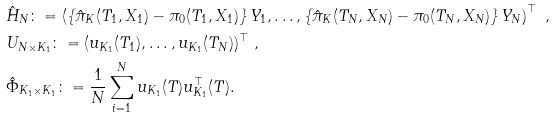<formula> <loc_0><loc_0><loc_500><loc_500>& \hat { H } _ { N } \colon = \left ( \left \{ \hat { \pi } _ { K } ( T _ { 1 } , X _ { 1 } ) - { \pi } _ { 0 } ( T _ { 1 } , X _ { 1 } ) \right \} Y _ { 1 } , \dots , \left \{ \hat { \pi } _ { K } ( T _ { N } , X _ { N } ) - { \pi } _ { 0 } ( T _ { N } , X _ { N } ) \right \} Y _ { N } \right ) ^ { \top } \ , \\ & U _ { N \times K _ { 1 } } \colon = ( u _ { K _ { 1 } } ( T _ { 1 } ) , \dots , u _ { K _ { 1 } } ( T _ { N } ) ) ^ { \top } \ , \\ & \hat { \Phi } _ { K _ { 1 } \times K _ { 1 } } \colon = \frac { 1 } { N } \sum _ { i = 1 } ^ { N } u _ { K _ { 1 } } ( T ) u _ { K _ { 1 } } ^ { \top } ( T ) .</formula> 